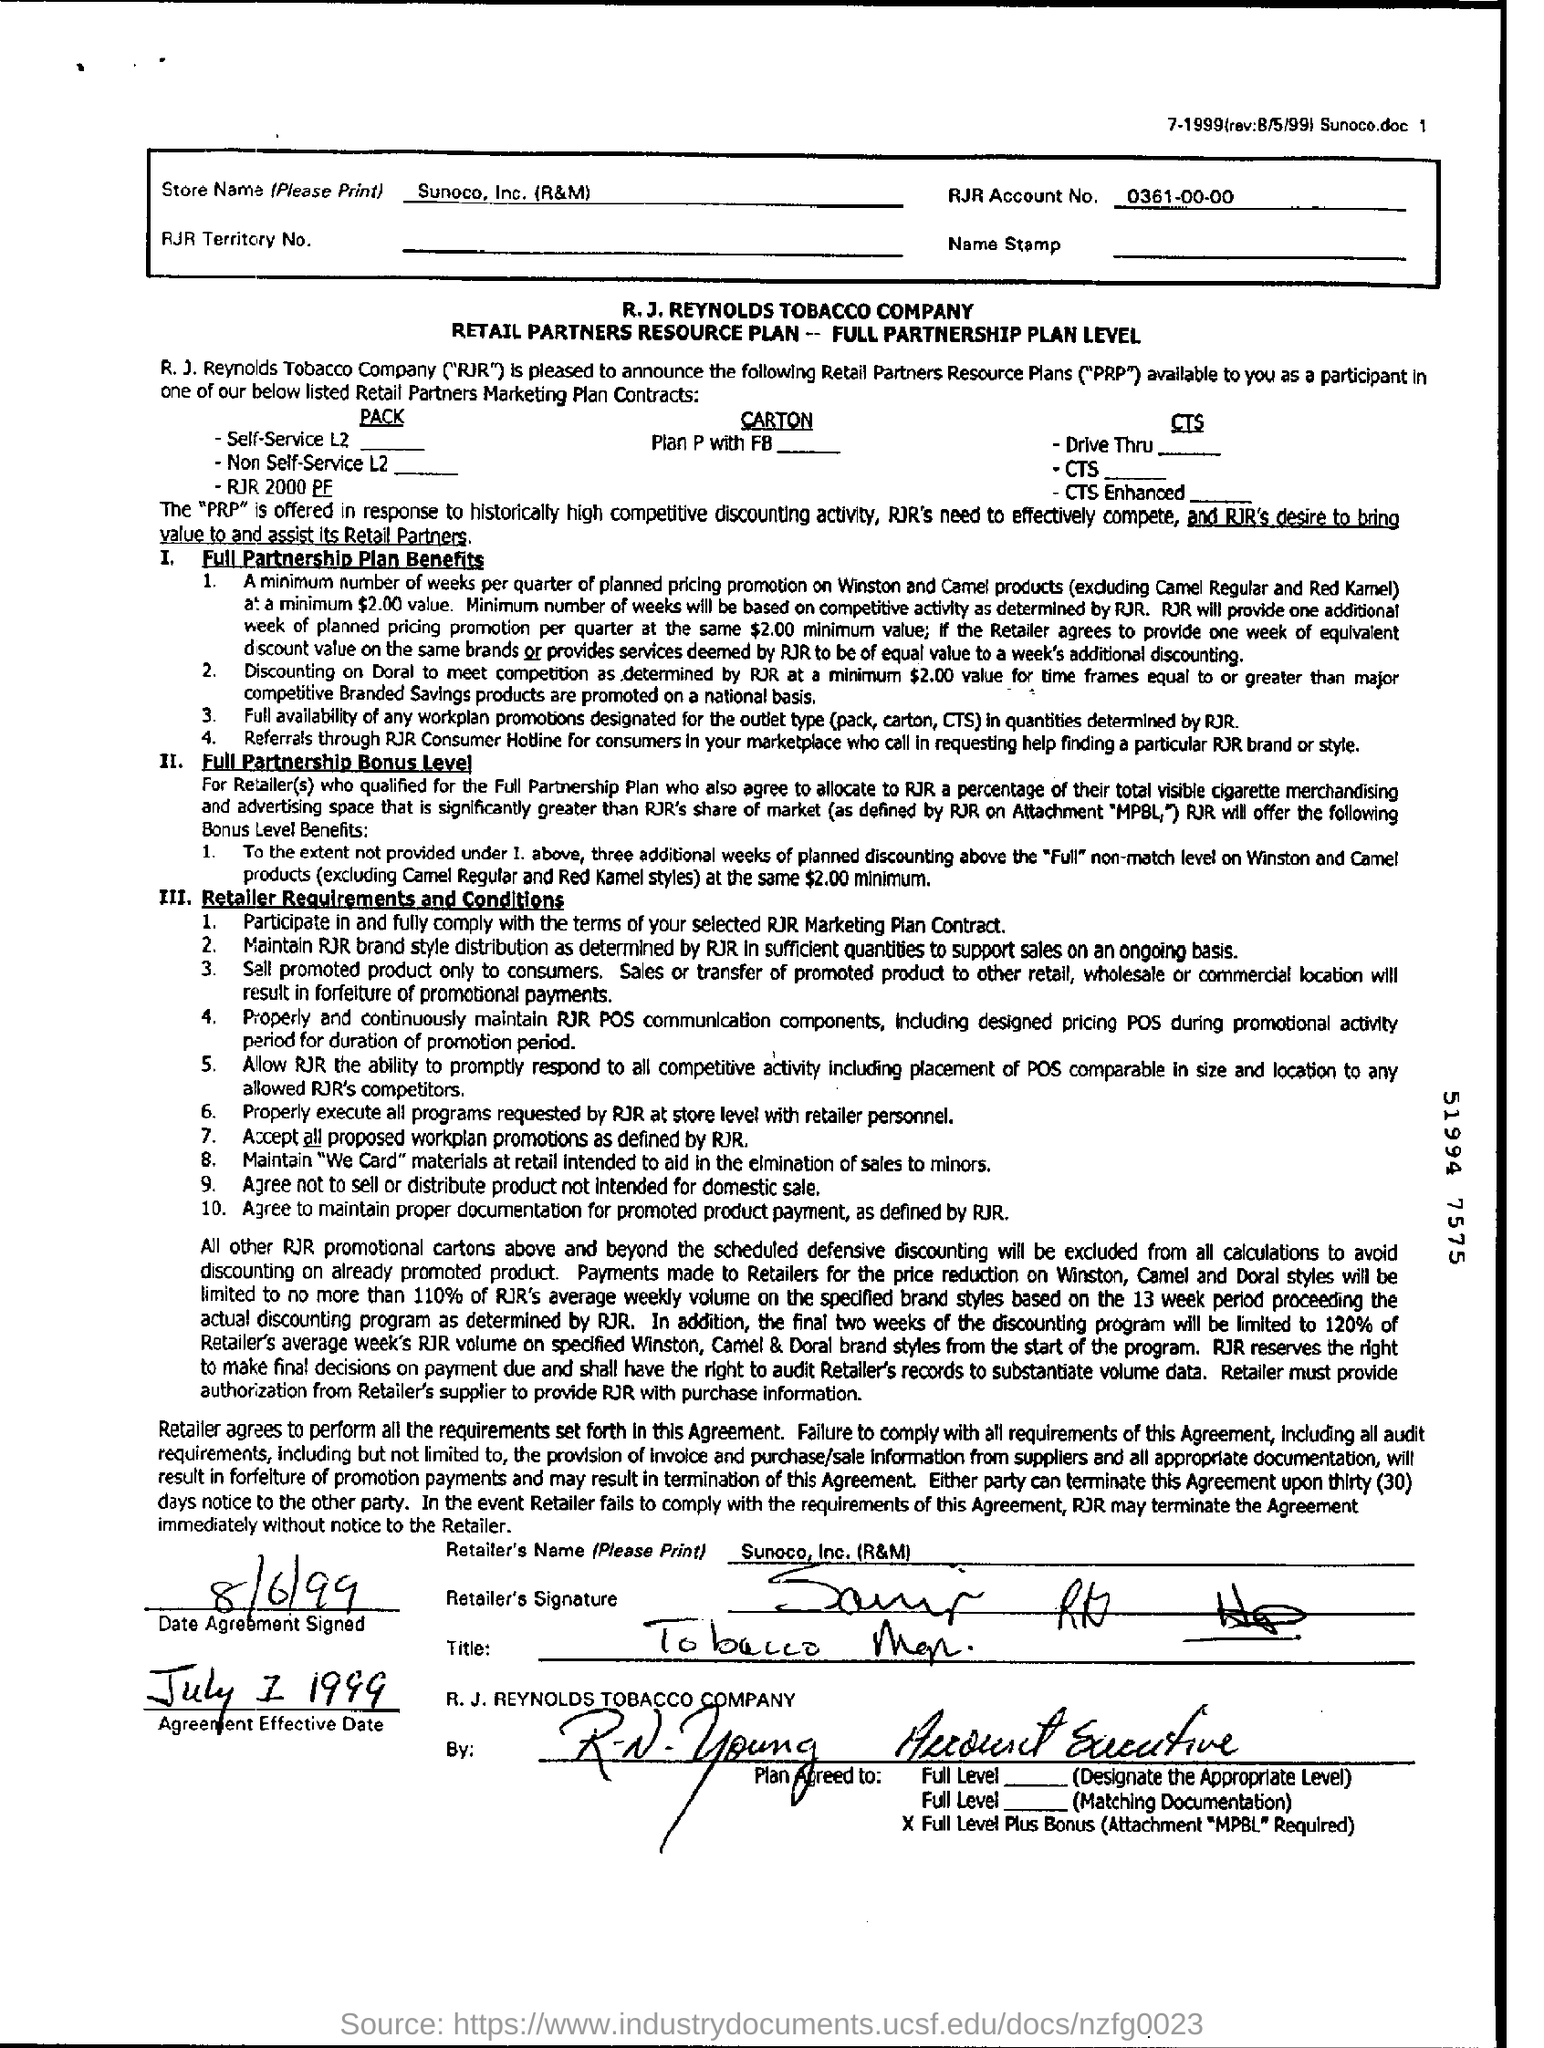Mention a couple of crucial points in this snapshot. The document provides the name of the retailer as Sunoco, Inc. (R&M). The Agreement Effective Date is July 1, 1999. The date of agreement signed was August 6, 1999. The RJR account number is 0361-00-00.. 